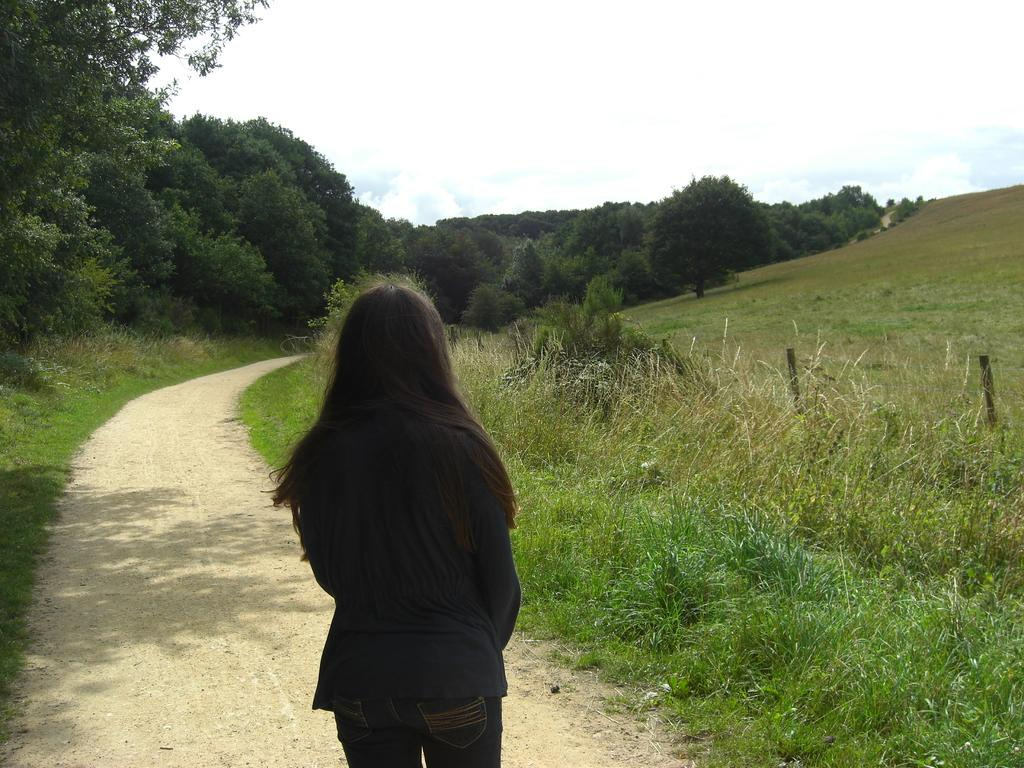What is the main subject of the image? There is a woman standing in the image. What is the woman standing on? The woman is standing on the ground. What type of vegetation can be seen in the image? There are trees and grass in the image. What is visible in the background of the image? The sky is visible in the background of the image. What can be seen in the sky? Clouds are present in the sky. What type of drawer can be seen in the image? There is no drawer present in the image. What is the plot of the story being told in the image? The image does not depict a story or plot; it is a simple scene of a woman standing in a natural setting. 